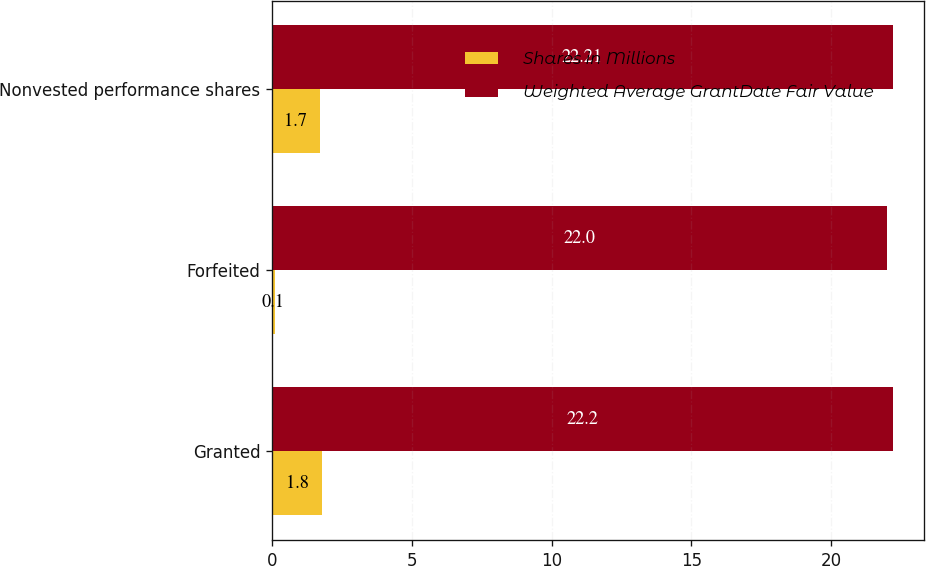Convert chart to OTSL. <chart><loc_0><loc_0><loc_500><loc_500><stacked_bar_chart><ecel><fcel>Granted<fcel>Forfeited<fcel>Nonvested performance shares<nl><fcel>Shares in Millions<fcel>1.8<fcel>0.1<fcel>1.7<nl><fcel>Weighted Average GrantDate Fair Value<fcel>22.2<fcel>22<fcel>22.21<nl></chart> 